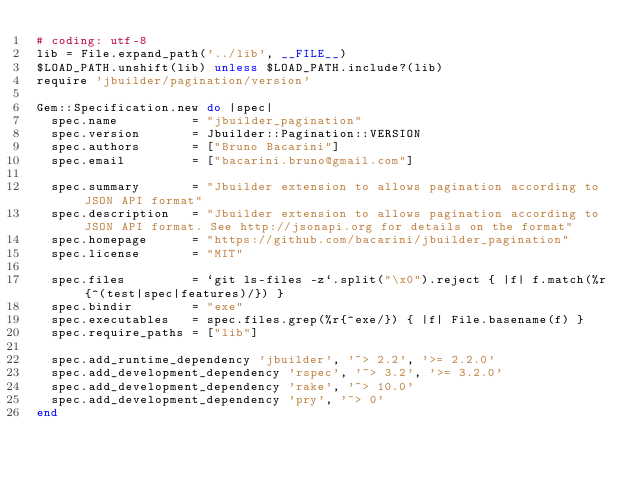<code> <loc_0><loc_0><loc_500><loc_500><_Ruby_># coding: utf-8
lib = File.expand_path('../lib', __FILE__)
$LOAD_PATH.unshift(lib) unless $LOAD_PATH.include?(lib)
require 'jbuilder/pagination/version'

Gem::Specification.new do |spec|
  spec.name          = "jbuilder_pagination"
  spec.version       = Jbuilder::Pagination::VERSION
  spec.authors       = ["Bruno Bacarini"]
  spec.email         = ["bacarini.bruno@gmail.com"]

  spec.summary       = "Jbuilder extension to allows pagination according to JSON API format"
  spec.description   = "Jbuilder extension to allows pagination according to JSON API format. See http://jsonapi.org for details on the format"
  spec.homepage      = "https://github.com/bacarini/jbuilder_pagination"
  spec.license       = "MIT"

  spec.files         = `git ls-files -z`.split("\x0").reject { |f| f.match(%r{^(test|spec|features)/}) }
  spec.bindir        = "exe"
  spec.executables   = spec.files.grep(%r{^exe/}) { |f| File.basename(f) }
  spec.require_paths = ["lib"]

  spec.add_runtime_dependency 'jbuilder', '~> 2.2', '>= 2.2.0'
  spec.add_development_dependency 'rspec', '~> 3.2', '>= 3.2.0'
  spec.add_development_dependency 'rake', '~> 10.0'
  spec.add_development_dependency 'pry', '~> 0'
end
</code> 